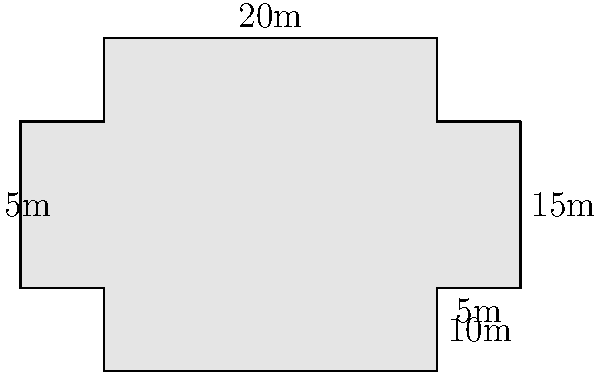As a new seminary student, you've been asked to calculate the perimeter of your church's unique cross-shaped floor plan for a renovation project. The main sanctuary is 20m wide and 15m long, with two identical transepts (side extensions) that are 5m wide and 10m long each. What is the total perimeter of the church floor plan? Let's approach this step-by-step:

1) First, let's identify the parts of the perimeter:
   - The front and back of the main sanctuary
   - The sides of the main sanctuary minus the width of the transepts
   - The outer edges of both transepts

2) Calculate each part:
   - Front and back of sanctuary: $20m \times 2 = 40m$
   - Sides of sanctuary: $(15m - 5m) \times 2 = 20m$
     (We subtract 5m from each side because that's where the transepts connect)
   - Outer edges of transepts: $10m \times 4 = 40m$
     (Each transept adds two 10m sides to the perimeter)

3) Sum up all parts:
   $40m + 20m + 40m = 100m$

Therefore, the total perimeter of the church floor plan is 100 meters.
Answer: 100 meters 